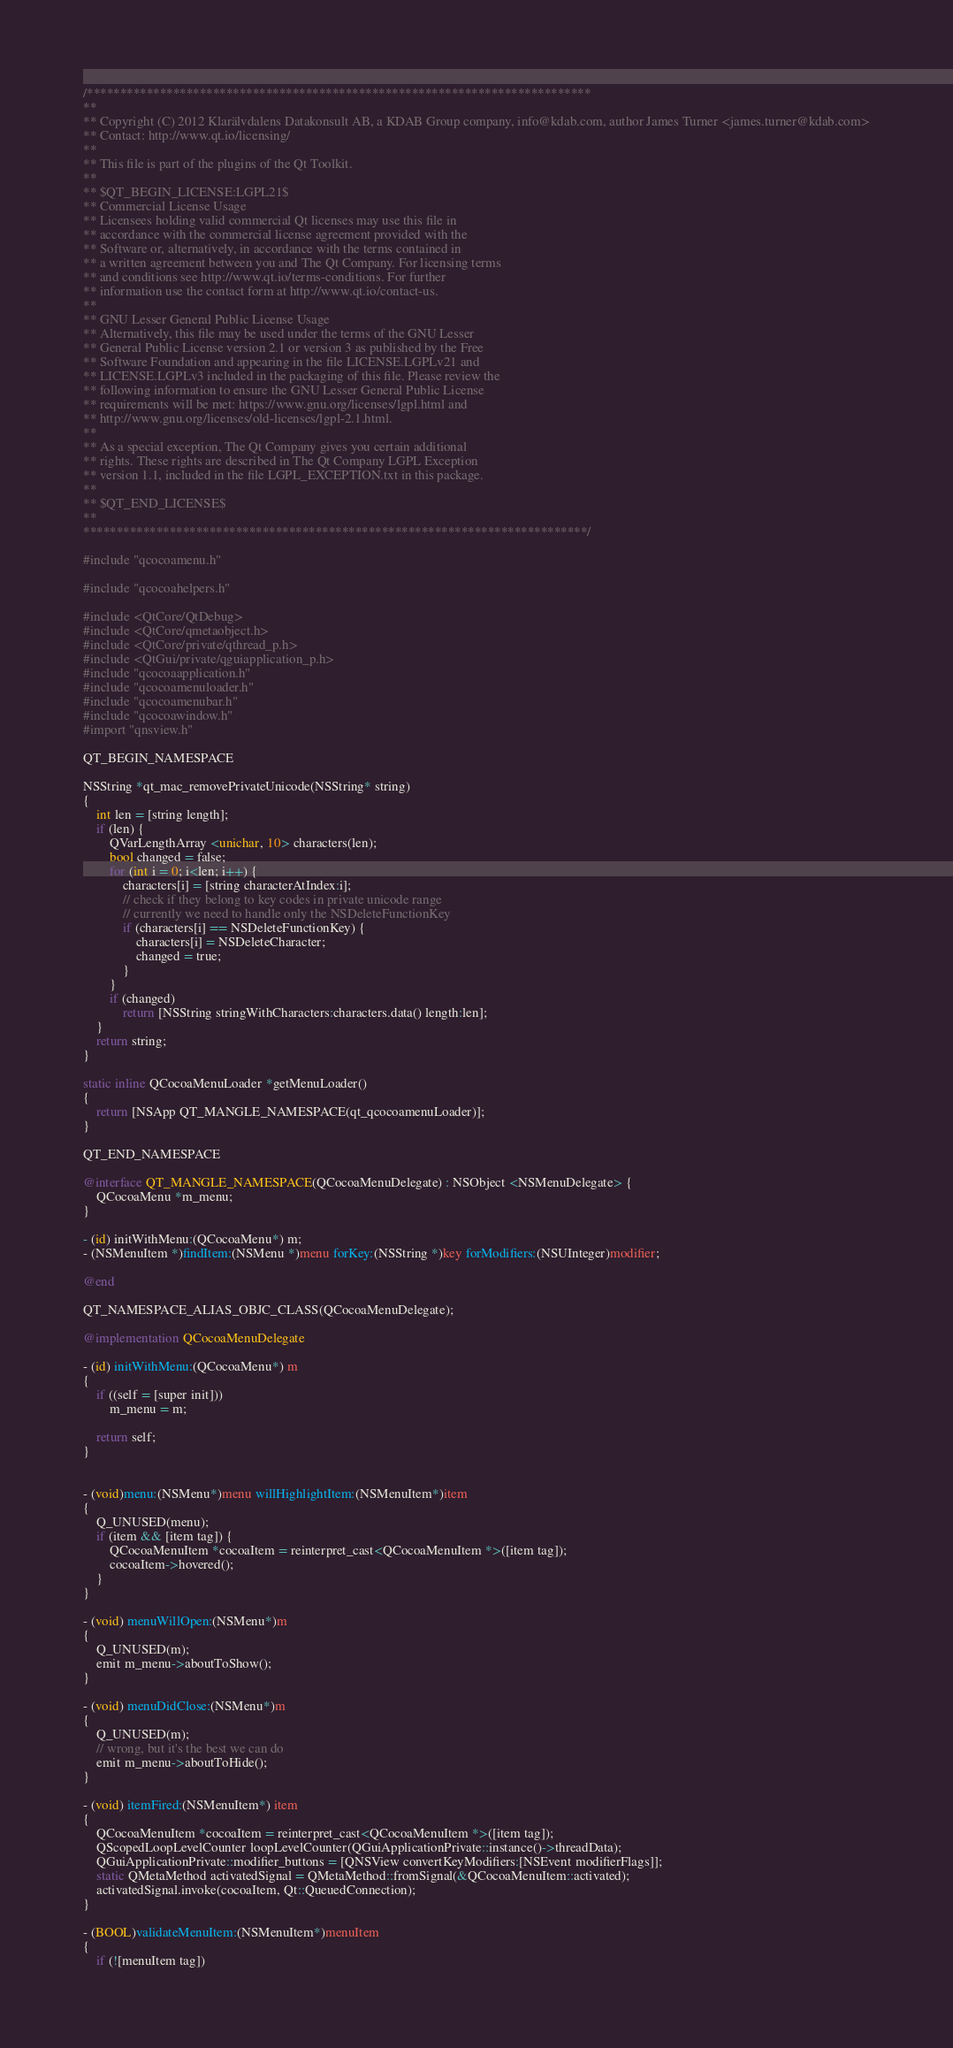<code> <loc_0><loc_0><loc_500><loc_500><_ObjectiveC_>/****************************************************************************
**
** Copyright (C) 2012 Klarälvdalens Datakonsult AB, a KDAB Group company, info@kdab.com, author James Turner <james.turner@kdab.com>
** Contact: http://www.qt.io/licensing/
**
** This file is part of the plugins of the Qt Toolkit.
**
** $QT_BEGIN_LICENSE:LGPL21$
** Commercial License Usage
** Licensees holding valid commercial Qt licenses may use this file in
** accordance with the commercial license agreement provided with the
** Software or, alternatively, in accordance with the terms contained in
** a written agreement between you and The Qt Company. For licensing terms
** and conditions see http://www.qt.io/terms-conditions. For further
** information use the contact form at http://www.qt.io/contact-us.
**
** GNU Lesser General Public License Usage
** Alternatively, this file may be used under the terms of the GNU Lesser
** General Public License version 2.1 or version 3 as published by the Free
** Software Foundation and appearing in the file LICENSE.LGPLv21 and
** LICENSE.LGPLv3 included in the packaging of this file. Please review the
** following information to ensure the GNU Lesser General Public License
** requirements will be met: https://www.gnu.org/licenses/lgpl.html and
** http://www.gnu.org/licenses/old-licenses/lgpl-2.1.html.
**
** As a special exception, The Qt Company gives you certain additional
** rights. These rights are described in The Qt Company LGPL Exception
** version 1.1, included in the file LGPL_EXCEPTION.txt in this package.
**
** $QT_END_LICENSE$
**
****************************************************************************/

#include "qcocoamenu.h"

#include "qcocoahelpers.h"

#include <QtCore/QtDebug>
#include <QtCore/qmetaobject.h>
#include <QtCore/private/qthread_p.h>
#include <QtGui/private/qguiapplication_p.h>
#include "qcocoaapplication.h"
#include "qcocoamenuloader.h"
#include "qcocoamenubar.h"
#include "qcocoawindow.h"
#import "qnsview.h"

QT_BEGIN_NAMESPACE

NSString *qt_mac_removePrivateUnicode(NSString* string)
{
    int len = [string length];
    if (len) {
        QVarLengthArray <unichar, 10> characters(len);
        bool changed = false;
        for (int i = 0; i<len; i++) {
            characters[i] = [string characterAtIndex:i];
            // check if they belong to key codes in private unicode range
            // currently we need to handle only the NSDeleteFunctionKey
            if (characters[i] == NSDeleteFunctionKey) {
                characters[i] = NSDeleteCharacter;
                changed = true;
            }
        }
        if (changed)
            return [NSString stringWithCharacters:characters.data() length:len];
    }
    return string;
}

static inline QCocoaMenuLoader *getMenuLoader()
{
    return [NSApp QT_MANGLE_NAMESPACE(qt_qcocoamenuLoader)];
}

QT_END_NAMESPACE

@interface QT_MANGLE_NAMESPACE(QCocoaMenuDelegate) : NSObject <NSMenuDelegate> {
    QCocoaMenu *m_menu;
}

- (id) initWithMenu:(QCocoaMenu*) m;
- (NSMenuItem *)findItem:(NSMenu *)menu forKey:(NSString *)key forModifiers:(NSUInteger)modifier;

@end

QT_NAMESPACE_ALIAS_OBJC_CLASS(QCocoaMenuDelegate);

@implementation QCocoaMenuDelegate

- (id) initWithMenu:(QCocoaMenu*) m
{
    if ((self = [super init]))
        m_menu = m;

    return self;
}


- (void)menu:(NSMenu*)menu willHighlightItem:(NSMenuItem*)item
{
    Q_UNUSED(menu);
    if (item && [item tag]) {
        QCocoaMenuItem *cocoaItem = reinterpret_cast<QCocoaMenuItem *>([item tag]);
        cocoaItem->hovered();
    }
}

- (void) menuWillOpen:(NSMenu*)m
{
    Q_UNUSED(m);
    emit m_menu->aboutToShow();
}

- (void) menuDidClose:(NSMenu*)m
{
    Q_UNUSED(m);
    // wrong, but it's the best we can do
    emit m_menu->aboutToHide();
}

- (void) itemFired:(NSMenuItem*) item
{
    QCocoaMenuItem *cocoaItem = reinterpret_cast<QCocoaMenuItem *>([item tag]);
    QScopedLoopLevelCounter loopLevelCounter(QGuiApplicationPrivate::instance()->threadData);
    QGuiApplicationPrivate::modifier_buttons = [QNSView convertKeyModifiers:[NSEvent modifierFlags]];
    static QMetaMethod activatedSignal = QMetaMethod::fromSignal(&QCocoaMenuItem::activated);
    activatedSignal.invoke(cocoaItem, Qt::QueuedConnection);
}

- (BOOL)validateMenuItem:(NSMenuItem*)menuItem
{
    if (![menuItem tag])</code> 